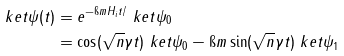Convert formula to latex. <formula><loc_0><loc_0><loc_500><loc_500>\ k e t { \psi ( t ) } & = e ^ { - \i m H _ { i } t / } \ k e t { \psi _ { 0 } } \\ & = \cos ( \sqrt { n } \gamma t ) \ k e t { \psi _ { 0 } } - \i m \sin ( \sqrt { n } \gamma t ) \ k e t { \psi _ { 1 } }</formula> 